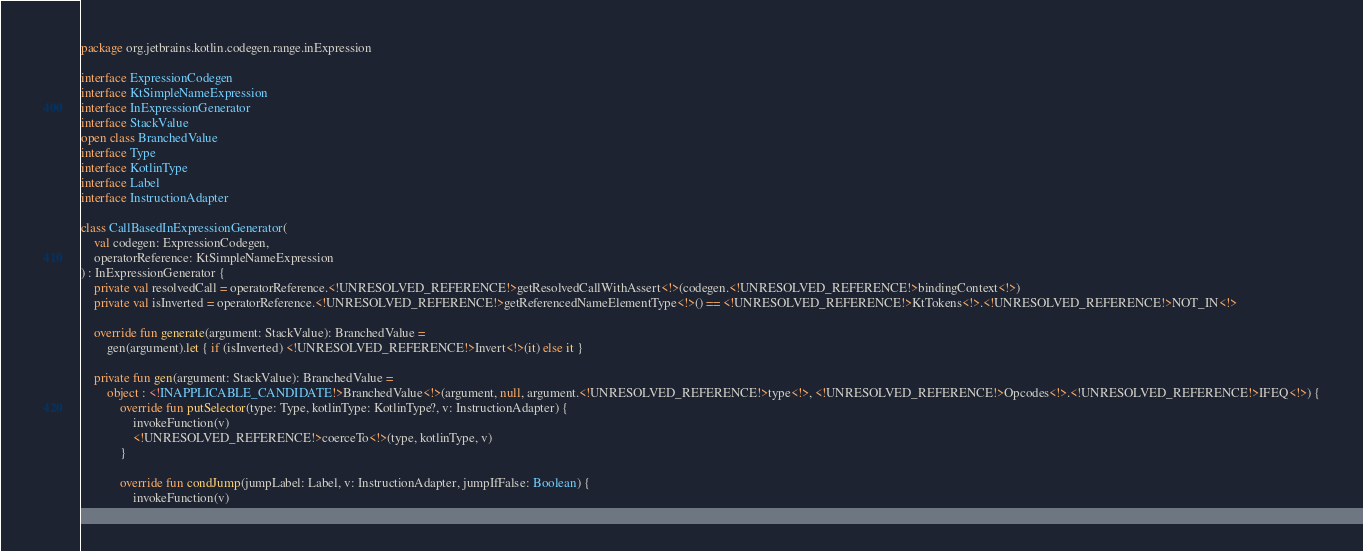<code> <loc_0><loc_0><loc_500><loc_500><_Kotlin_>package org.jetbrains.kotlin.codegen.range.inExpression

interface ExpressionCodegen
interface KtSimpleNameExpression
interface InExpressionGenerator
interface StackValue
open class BranchedValue
interface Type
interface KotlinType
interface Label
interface InstructionAdapter

class CallBasedInExpressionGenerator(
    val codegen: ExpressionCodegen,
    operatorReference: KtSimpleNameExpression
) : InExpressionGenerator {
    private val resolvedCall = operatorReference.<!UNRESOLVED_REFERENCE!>getResolvedCallWithAssert<!>(codegen.<!UNRESOLVED_REFERENCE!>bindingContext<!>)
    private val isInverted = operatorReference.<!UNRESOLVED_REFERENCE!>getReferencedNameElementType<!>() == <!UNRESOLVED_REFERENCE!>KtTokens<!>.<!UNRESOLVED_REFERENCE!>NOT_IN<!>

    override fun generate(argument: StackValue): BranchedValue =
        gen(argument).let { if (isInverted) <!UNRESOLVED_REFERENCE!>Invert<!>(it) else it }

    private fun gen(argument: StackValue): BranchedValue =
        object : <!INAPPLICABLE_CANDIDATE!>BranchedValue<!>(argument, null, argument.<!UNRESOLVED_REFERENCE!>type<!>, <!UNRESOLVED_REFERENCE!>Opcodes<!>.<!UNRESOLVED_REFERENCE!>IFEQ<!>) {
            override fun putSelector(type: Type, kotlinType: KotlinType?, v: InstructionAdapter) {
                invokeFunction(v)
                <!UNRESOLVED_REFERENCE!>coerceTo<!>(type, kotlinType, v)
            }

            override fun condJump(jumpLabel: Label, v: InstructionAdapter, jumpIfFalse: Boolean) {
                invokeFunction(v)</code> 